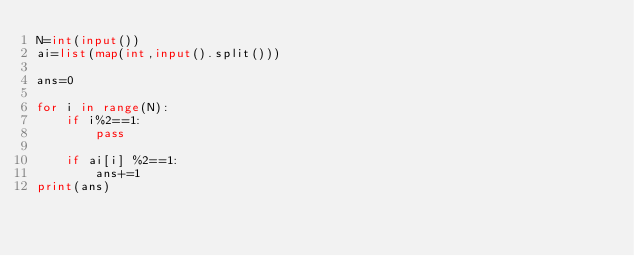Convert code to text. <code><loc_0><loc_0><loc_500><loc_500><_Python_>N=int(input())
ai=list(map(int,input().split()))

ans=0

for i in range(N):
    if i%2==1:
        pass

    if ai[i] %2==1:
        ans+=1
print(ans)</code> 